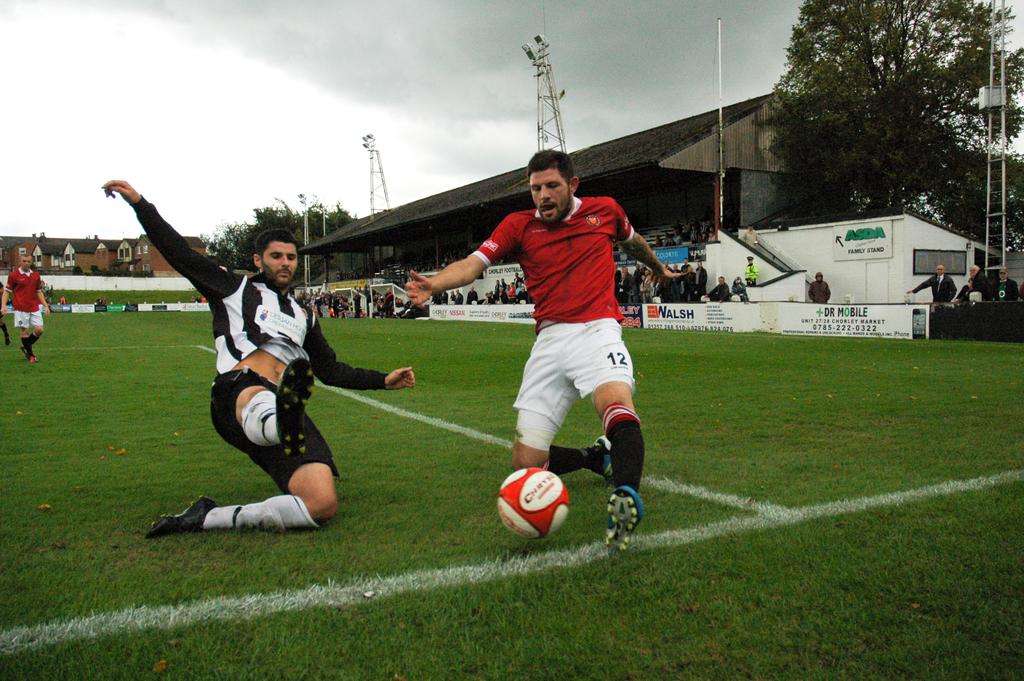What number is the player in the white shorts?
Make the answer very short. 12. What is the name of an advertiser on the wall?
Ensure brevity in your answer.  Asda. 